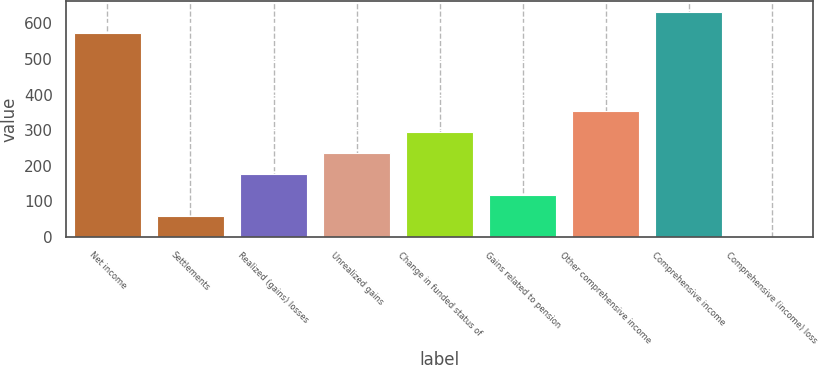<chart> <loc_0><loc_0><loc_500><loc_500><bar_chart><fcel>Net income<fcel>Settlements<fcel>Realized (gains) losses<fcel>Unrealized gains<fcel>Change in funded status of<fcel>Gains related to pension<fcel>Other comprehensive income<fcel>Comprehensive income<fcel>Comprehensive (income) loss<nl><fcel>572.1<fcel>59.05<fcel>176.55<fcel>235.3<fcel>294.05<fcel>117.8<fcel>352.8<fcel>630.85<fcel>0.3<nl></chart> 